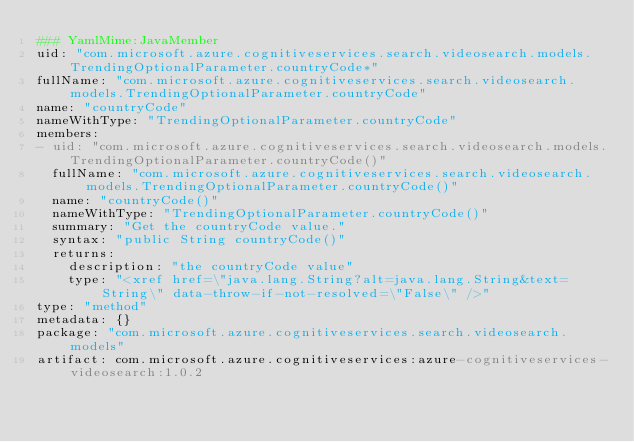<code> <loc_0><loc_0><loc_500><loc_500><_YAML_>### YamlMime:JavaMember
uid: "com.microsoft.azure.cognitiveservices.search.videosearch.models.TrendingOptionalParameter.countryCode*"
fullName: "com.microsoft.azure.cognitiveservices.search.videosearch.models.TrendingOptionalParameter.countryCode"
name: "countryCode"
nameWithType: "TrendingOptionalParameter.countryCode"
members:
- uid: "com.microsoft.azure.cognitiveservices.search.videosearch.models.TrendingOptionalParameter.countryCode()"
  fullName: "com.microsoft.azure.cognitiveservices.search.videosearch.models.TrendingOptionalParameter.countryCode()"
  name: "countryCode()"
  nameWithType: "TrendingOptionalParameter.countryCode()"
  summary: "Get the countryCode value."
  syntax: "public String countryCode()"
  returns:
    description: "the countryCode value"
    type: "<xref href=\"java.lang.String?alt=java.lang.String&text=String\" data-throw-if-not-resolved=\"False\" />"
type: "method"
metadata: {}
package: "com.microsoft.azure.cognitiveservices.search.videosearch.models"
artifact: com.microsoft.azure.cognitiveservices:azure-cognitiveservices-videosearch:1.0.2
</code> 